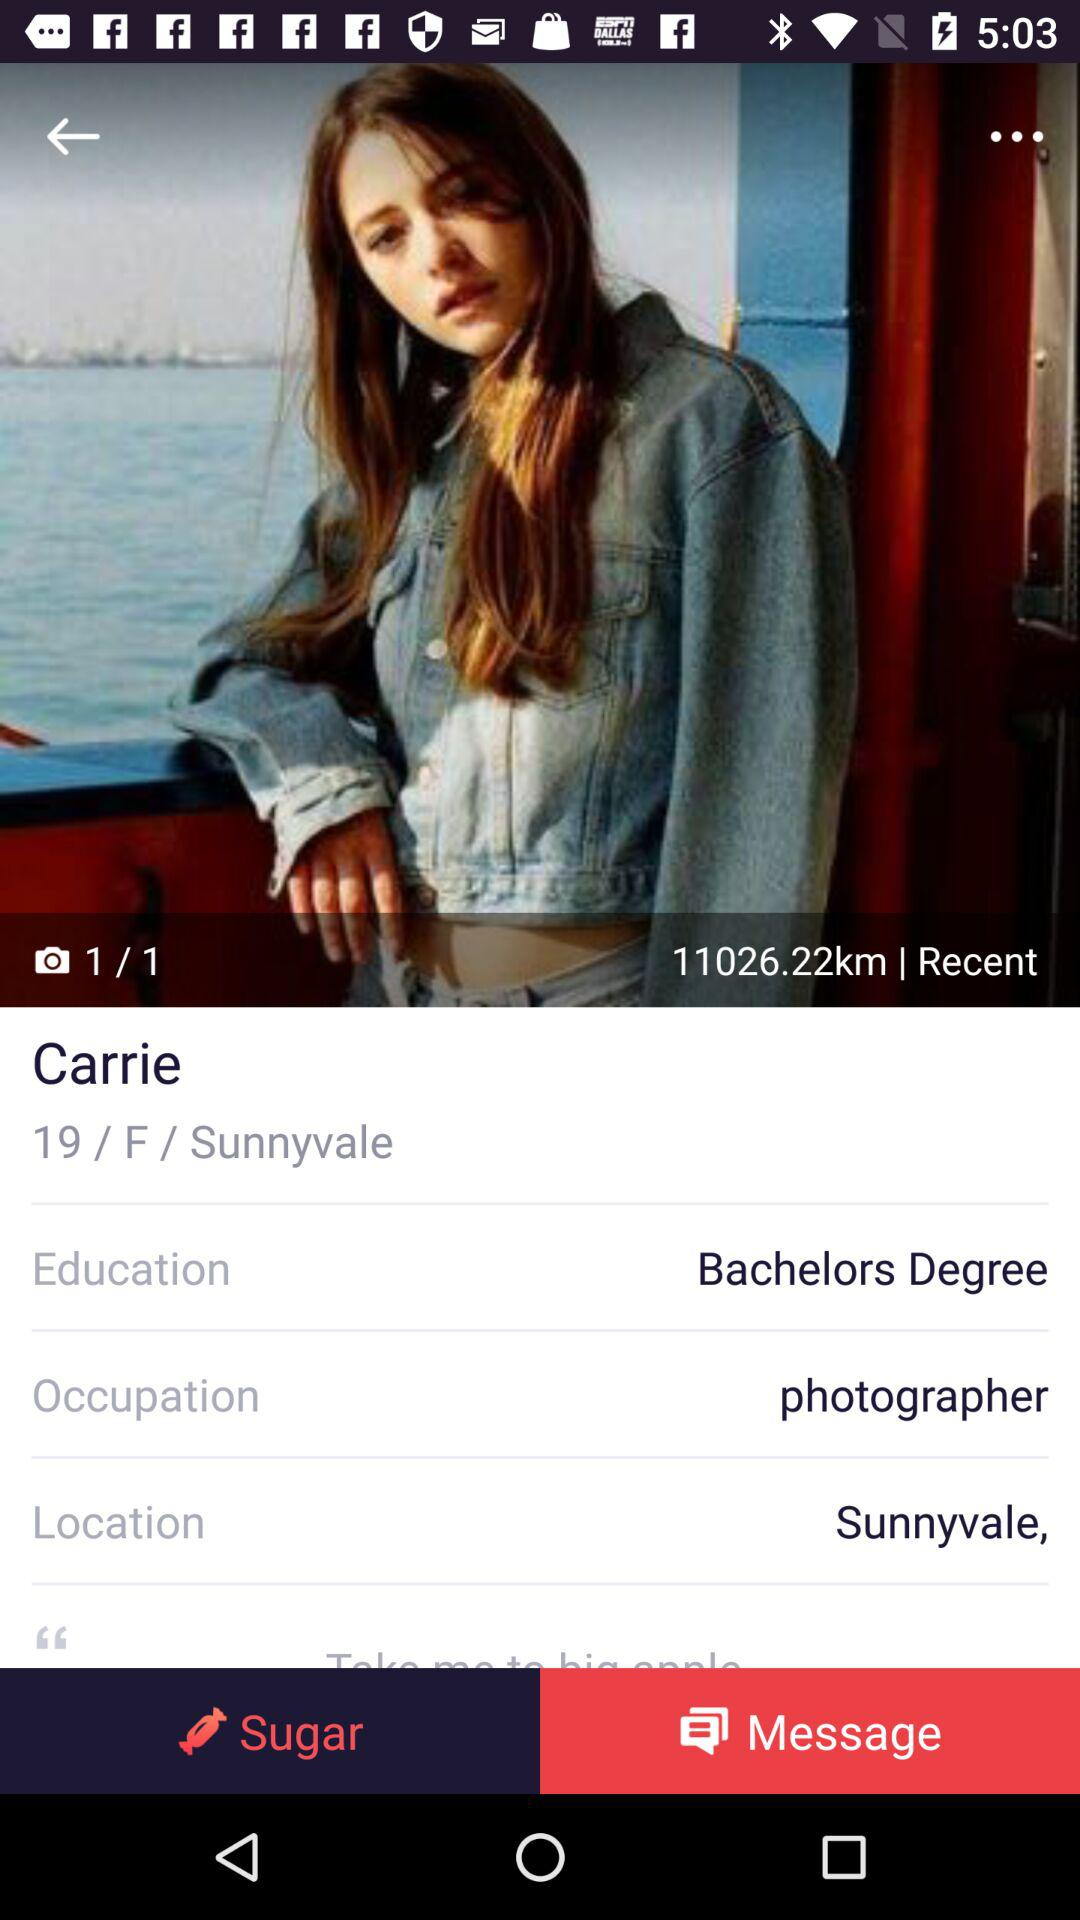How many kilometres are shown in the image? The shown kilometres are 11026.22. 